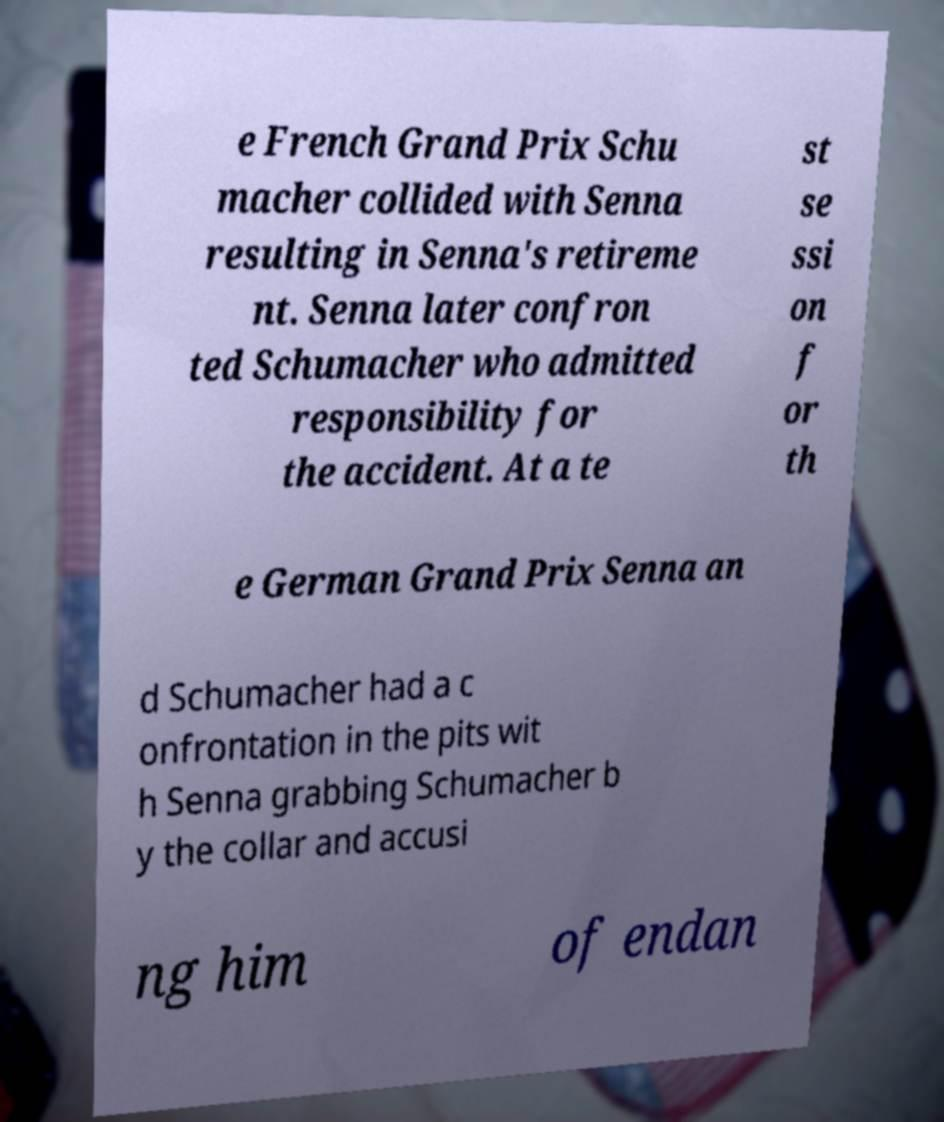Could you assist in decoding the text presented in this image and type it out clearly? e French Grand Prix Schu macher collided with Senna resulting in Senna's retireme nt. Senna later confron ted Schumacher who admitted responsibility for the accident. At a te st se ssi on f or th e German Grand Prix Senna an d Schumacher had a c onfrontation in the pits wit h Senna grabbing Schumacher b y the collar and accusi ng him of endan 